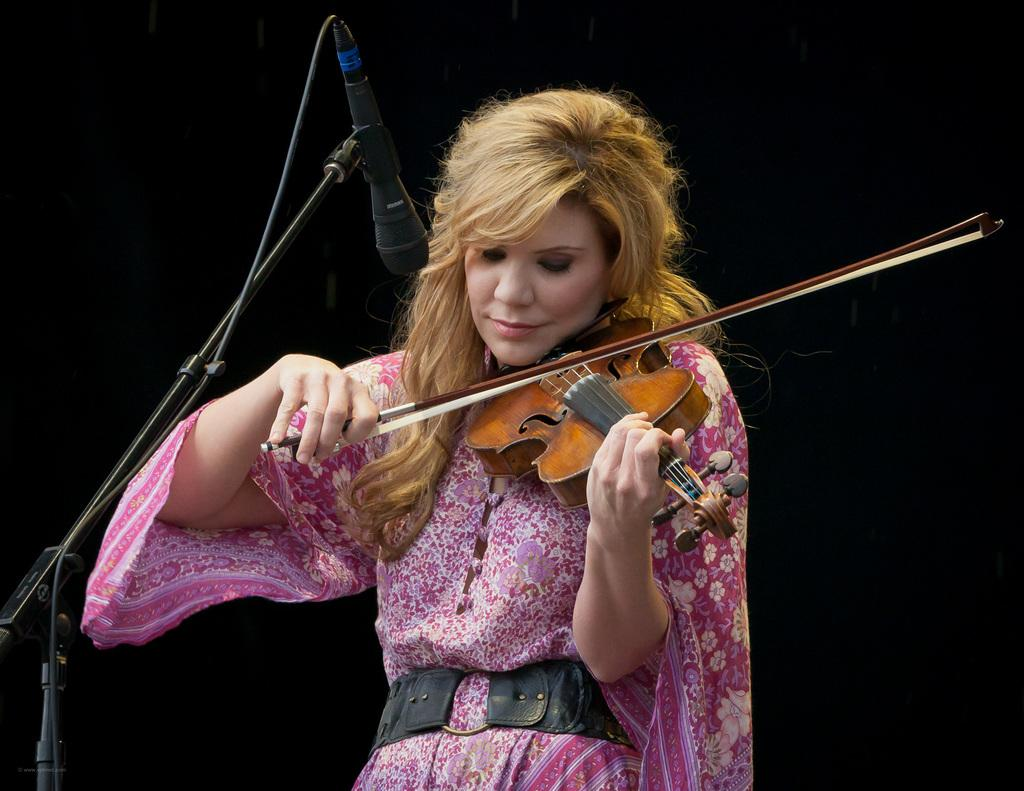Who is the main subject in the image? There is a woman in the image. Can you describe the woman's hair? The woman has golden silky hair. What is the woman wearing in the image? The woman is wearing a colorful pink dress. What is the woman holding in her hand? The woman is holding a violin in her hand. What is the woman doing with the violin? The woman is playing the violin. What objects are in front of the woman? There are microphones in front of the woman. What year is the woman celebrating her birthday in the image? There is no indication of a birthday or a specific year in the image. 